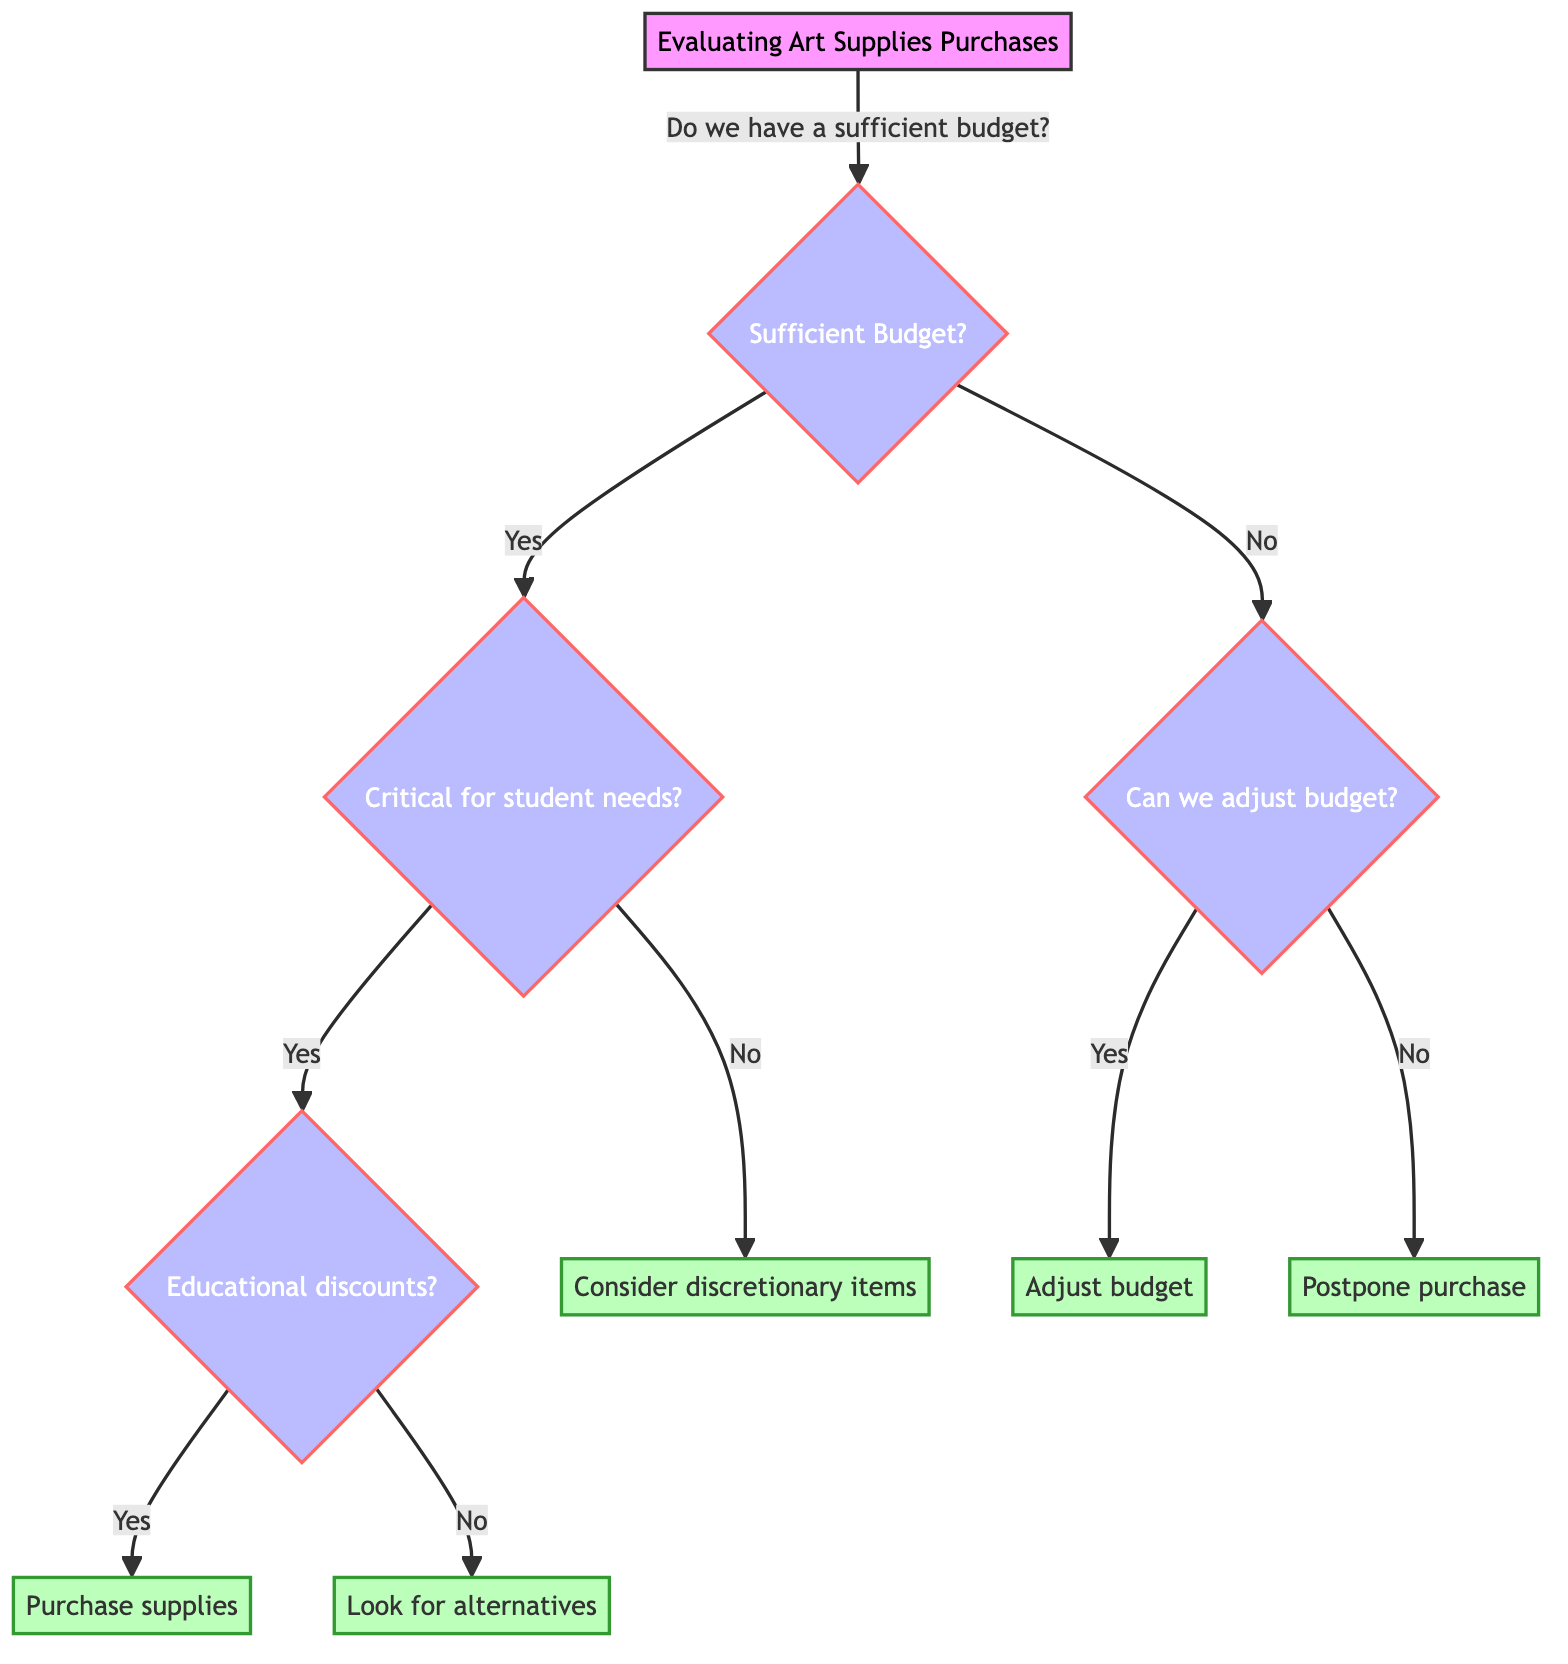What is the first question in the diagram? The first question in the diagram, which is located at the top, is about whether there is a sufficient budget.
Answer: Do we have a sufficient budget? How many possible actions can be taken if there is a sufficient budget? If there is a sufficient budget, two potential paths can be taken: either making a purchase if the supplies are critical and the supplier offers discounts or looking for alternatives if there are no discounts.
Answer: Two What happens if the supplies are not critical for meeting student needs and there is a sufficient budget? The flow indicates that if the budget is sufficient but the supplies are not critical, the next action suggested is to consider discretionary items.
Answer: Consider discretionary items If there is insufficient budget and no way to adjust it, what is the action? In the scenario where the budget is insufficient and cannot be adjusted, the action specified is to postpone the purchase.
Answer: Postpone purchase What node follows the question about educational discounts? It follows the question about educational discounts and asks if the supplier offers educational discounts or bulk purchase deals, leading to either a purchase or looking for alternatives.
Answer: Purchase supplies or Look for alternatives If there are educational discounts, what is the next step? If there are educational discounts, the next step is to purchase supplies from the chosen supplier, indicating that the purchase will proceed.
Answer: Purchase supplies What decision is made if the budget is insufficient but can be adjusted? If the budget is insufficient but can be adjusted, the action taken is to adjust the budget to accommodate the purchase of essential supplies.
Answer: Adjust budget How many questions are in the decision tree? The decision tree consists of four key questions that lead to final actions, capturing the flow from budget assessment to decisions based on student needs.
Answer: Four questions What is the overall theme of the decision tree? The overall theme of the decision tree is to evaluate art supplies purchases based on budget considerations and the needs of students, optimizing resource allocation effectively.
Answer: Evaluating art supplies purchases 